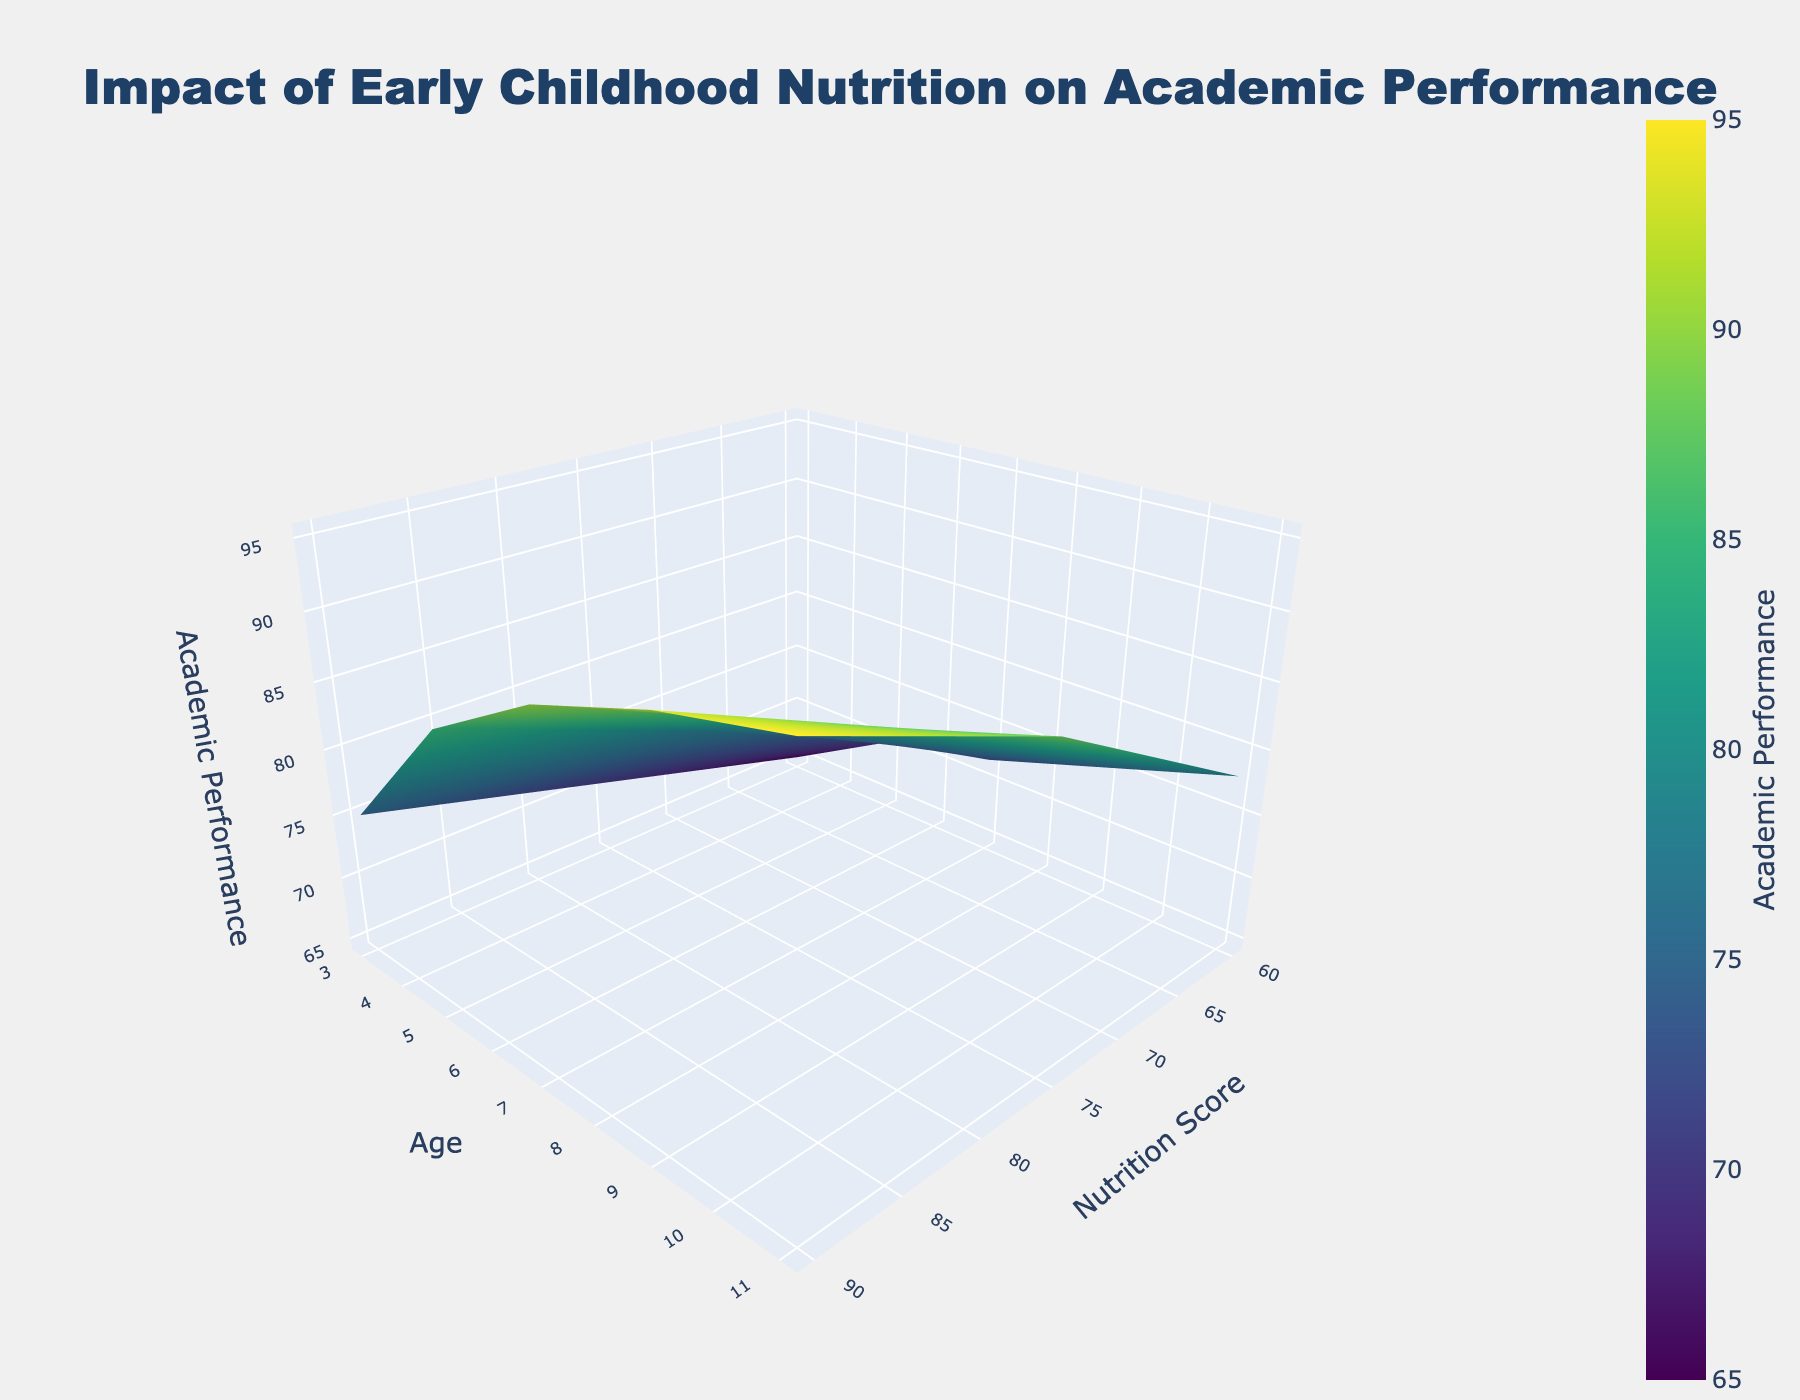What is the title of the figure? The title is usually found at the very top of the figure and is prominently displayed.
Answer: 'Impact of Early Childhood Nutrition on Academic Performance' What do the x-axis, y-axis, and z-axis represent? The axis titles are labeled on their respective axes in the figure. The x-axis represents 'Nutrition Score', the y-axis represents 'Age', and the z-axis represents 'Academic Performance'.
Answer: 'Nutrition Score' (x-axis), 'Age' (y-axis), 'Academic Performance' (z-axis) Which nutrition score category has the highest academic performance at age 11? Locate the age 11 on the y-axis and find the highest z-axis value for that age, corresponding to the nutrition score on the x-axis.
Answer: 90 How does academic performance change as age increases for a nutrition score of 75? Trace the line of the nutrition score 75 along the x-axis and observe the changes in academic performance values along the z-axis as the age values increase on the y-axis.
Answer: It increases steadily What is the change in academic performance from age 5 to age 9 for a nutrition score of 60? Locate the academic performance value at age 5 for nutrition score 60 and at age 9 for the same nutrition score, then calculate the difference between these values.
Answer: Increase by 5 Which age group shows the most improvement in academic performance with increasing nutrition score? Compare the slope of the surface plot across different age groups by looking at how sharply the values increase along the z-axis as the nutrition score increases along the x-axis.
Answer: Age 11 Is there any age where academic performance decreases with higher nutrition scores? Check the surface plot for any descending trends in academic performance values along the z-axis as the nutrition score increases along the x-axis for any age group.
Answer: No On average, how does academic performance change when nutrition score increases from 60 to 90? Average the academic performance values at different ages for nutrition scores 60 and 90, then find the difference between these averaged values.
Answer: It increases significantly Which nutrition score demonstrates the steepest increase in academic performance as children age? Compare the changes in academic performance for each nutrition score as age increases on the y-axis and identify the one with the steepest increase on the z-axis.
Answer: Nutrition score 90 Do younger children show less variation in academic performance based on nutrition compared to older children? Look at the spread and gradient of the academic performance values along the z-axis for younger age groups versus older age groups as nutrition score varies along the x-axis.
Answer: Yes 